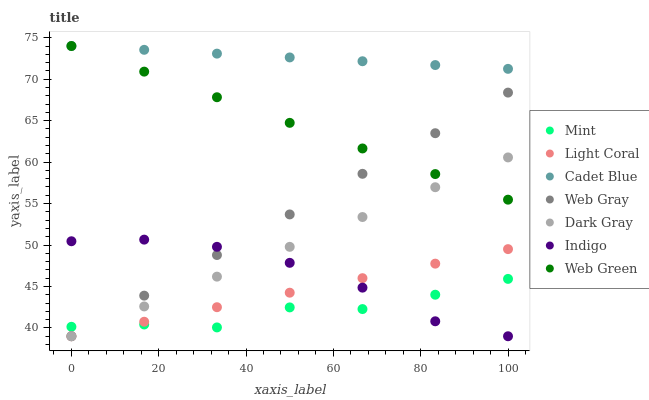Does Mint have the minimum area under the curve?
Answer yes or no. Yes. Does Cadet Blue have the maximum area under the curve?
Answer yes or no. Yes. Does Indigo have the minimum area under the curve?
Answer yes or no. No. Does Indigo have the maximum area under the curve?
Answer yes or no. No. Is Web Gray the smoothest?
Answer yes or no. Yes. Is Mint the roughest?
Answer yes or no. Yes. Is Cadet Blue the smoothest?
Answer yes or no. No. Is Cadet Blue the roughest?
Answer yes or no. No. Does Dark Gray have the lowest value?
Answer yes or no. Yes. Does Cadet Blue have the lowest value?
Answer yes or no. No. Does Web Green have the highest value?
Answer yes or no. Yes. Does Indigo have the highest value?
Answer yes or no. No. Is Mint less than Web Green?
Answer yes or no. Yes. Is Cadet Blue greater than Dark Gray?
Answer yes or no. Yes. Does Mint intersect Light Coral?
Answer yes or no. Yes. Is Mint less than Light Coral?
Answer yes or no. No. Is Mint greater than Light Coral?
Answer yes or no. No. Does Mint intersect Web Green?
Answer yes or no. No. 